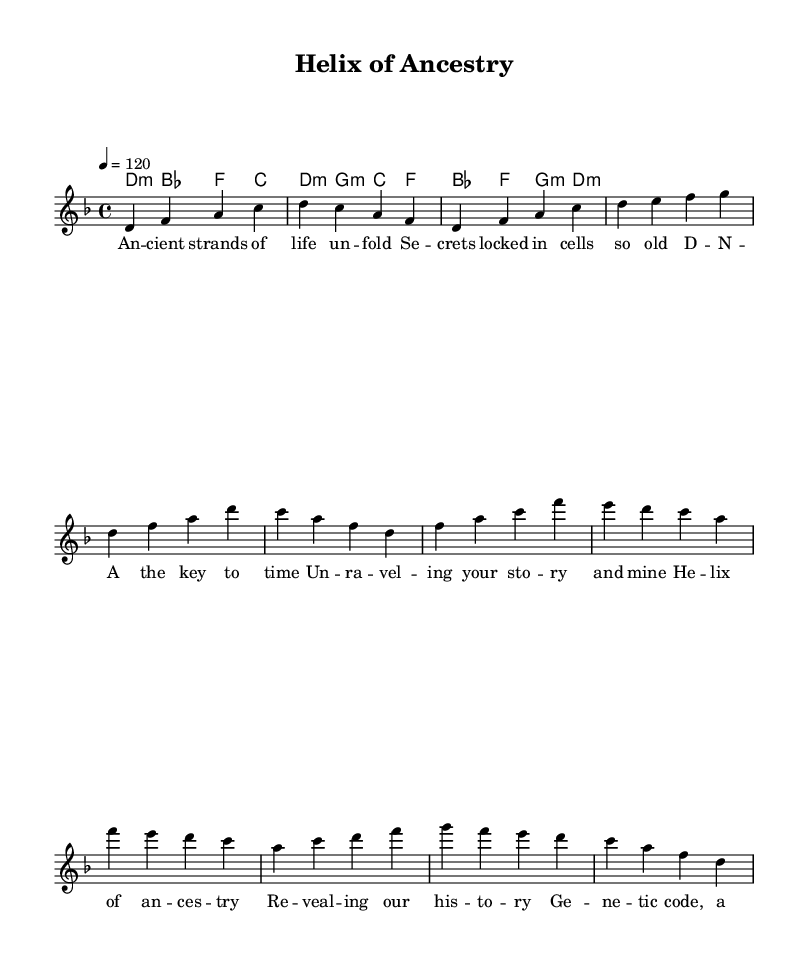What is the key signature of this music? The key signature is D minor, which includes one flat (B flat).
Answer: D minor What is the time signature of the piece? The time signature, indicated at the beginning of the score, is 4/4.
Answer: 4/4 What is the tempo marking of the composition? The tempo marking is indicated as 4 = 120, meaning there are 120 beats per minute.
Answer: 120 What are the lyrics of the chorus? The chorus lyrics are explicitly provided in the sheet music under the "chorus" section and read "Helix of ancestry revealing our history genetic code, a Latin beat past and present finally meet."
Answer: Helix of ancestry revealing our history genetic code, a Latin beat past and present finally meet How many measures are there in the verse? Counting the segments in the verses provided, there are 4 measures in the verse.
Answer: 4 Which chord appears first in the introduction? The first chord listed in the introduction is D minor, as shown in the chord names section.
Answer: D minor What rhythm styles are likely used in the piece? The melody and rhythm blend traditional Latin rhythms with modern influences, which suggests a fusion style.
Answer: Fusion style 